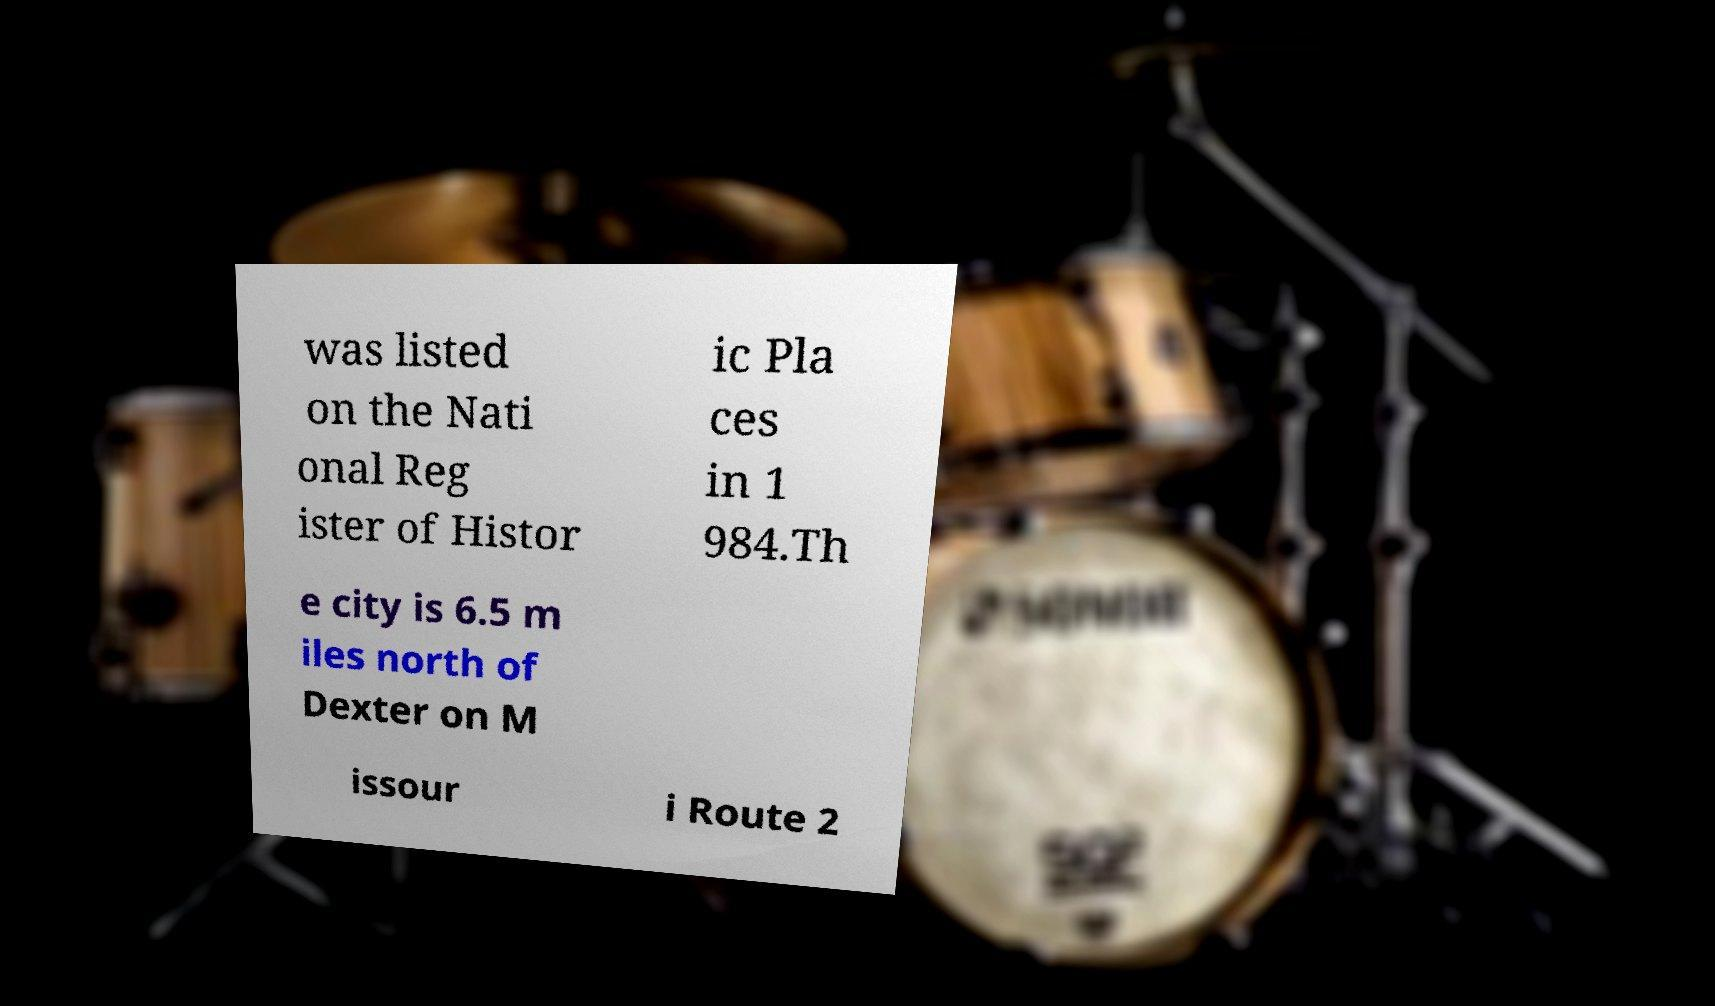Please identify and transcribe the text found in this image. was listed on the Nati onal Reg ister of Histor ic Pla ces in 1 984.Th e city is 6.5 m iles north of Dexter on M issour i Route 2 